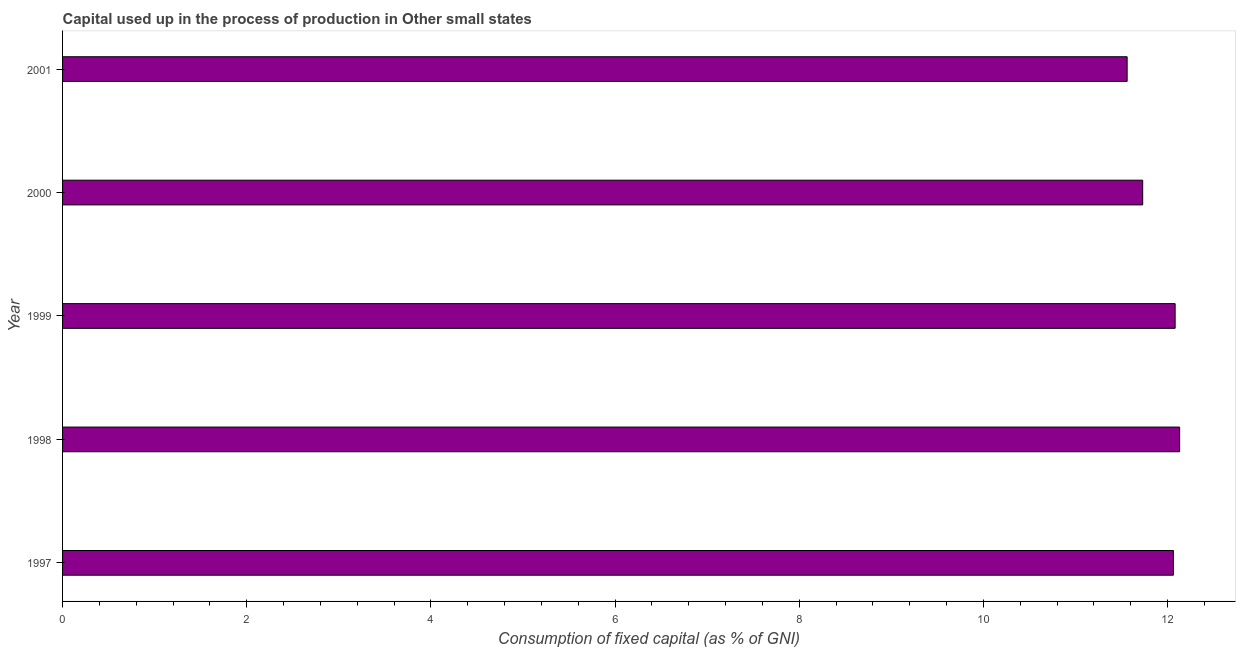Does the graph contain any zero values?
Provide a succinct answer. No. What is the title of the graph?
Your response must be concise. Capital used up in the process of production in Other small states. What is the label or title of the X-axis?
Make the answer very short. Consumption of fixed capital (as % of GNI). What is the consumption of fixed capital in 2000?
Give a very brief answer. 11.73. Across all years, what is the maximum consumption of fixed capital?
Offer a very short reply. 12.13. Across all years, what is the minimum consumption of fixed capital?
Make the answer very short. 11.56. In which year was the consumption of fixed capital maximum?
Give a very brief answer. 1998. What is the sum of the consumption of fixed capital?
Give a very brief answer. 59.57. What is the difference between the consumption of fixed capital in 1997 and 1998?
Make the answer very short. -0.07. What is the average consumption of fixed capital per year?
Offer a very short reply. 11.91. What is the median consumption of fixed capital?
Ensure brevity in your answer.  12.06. In how many years, is the consumption of fixed capital greater than 0.8 %?
Make the answer very short. 5. What is the ratio of the consumption of fixed capital in 1997 to that in 2000?
Your answer should be very brief. 1.03. Is the consumption of fixed capital in 1998 less than that in 2000?
Keep it short and to the point. No. What is the difference between the highest and the second highest consumption of fixed capital?
Offer a terse response. 0.05. What is the difference between the highest and the lowest consumption of fixed capital?
Make the answer very short. 0.57. In how many years, is the consumption of fixed capital greater than the average consumption of fixed capital taken over all years?
Give a very brief answer. 3. Are all the bars in the graph horizontal?
Make the answer very short. Yes. What is the Consumption of fixed capital (as % of GNI) of 1997?
Make the answer very short. 12.06. What is the Consumption of fixed capital (as % of GNI) in 1998?
Provide a short and direct response. 12.13. What is the Consumption of fixed capital (as % of GNI) of 1999?
Your answer should be compact. 12.08. What is the Consumption of fixed capital (as % of GNI) of 2000?
Offer a very short reply. 11.73. What is the Consumption of fixed capital (as % of GNI) of 2001?
Your response must be concise. 11.56. What is the difference between the Consumption of fixed capital (as % of GNI) in 1997 and 1998?
Offer a very short reply. -0.07. What is the difference between the Consumption of fixed capital (as % of GNI) in 1997 and 1999?
Keep it short and to the point. -0.02. What is the difference between the Consumption of fixed capital (as % of GNI) in 1997 and 2000?
Provide a succinct answer. 0.33. What is the difference between the Consumption of fixed capital (as % of GNI) in 1997 and 2001?
Provide a short and direct response. 0.5. What is the difference between the Consumption of fixed capital (as % of GNI) in 1998 and 1999?
Offer a terse response. 0.05. What is the difference between the Consumption of fixed capital (as % of GNI) in 1998 and 2000?
Keep it short and to the point. 0.4. What is the difference between the Consumption of fixed capital (as % of GNI) in 1998 and 2001?
Ensure brevity in your answer.  0.57. What is the difference between the Consumption of fixed capital (as % of GNI) in 1999 and 2000?
Make the answer very short. 0.35. What is the difference between the Consumption of fixed capital (as % of GNI) in 1999 and 2001?
Keep it short and to the point. 0.52. What is the difference between the Consumption of fixed capital (as % of GNI) in 2000 and 2001?
Offer a very short reply. 0.17. What is the ratio of the Consumption of fixed capital (as % of GNI) in 1997 to that in 1998?
Give a very brief answer. 0.99. What is the ratio of the Consumption of fixed capital (as % of GNI) in 1997 to that in 1999?
Keep it short and to the point. 1. What is the ratio of the Consumption of fixed capital (as % of GNI) in 1997 to that in 2000?
Offer a very short reply. 1.03. What is the ratio of the Consumption of fixed capital (as % of GNI) in 1997 to that in 2001?
Your answer should be compact. 1.04. What is the ratio of the Consumption of fixed capital (as % of GNI) in 1998 to that in 1999?
Your answer should be compact. 1. What is the ratio of the Consumption of fixed capital (as % of GNI) in 1998 to that in 2000?
Keep it short and to the point. 1.03. What is the ratio of the Consumption of fixed capital (as % of GNI) in 1998 to that in 2001?
Your answer should be compact. 1.05. What is the ratio of the Consumption of fixed capital (as % of GNI) in 1999 to that in 2000?
Keep it short and to the point. 1.03. What is the ratio of the Consumption of fixed capital (as % of GNI) in 1999 to that in 2001?
Keep it short and to the point. 1.04. What is the ratio of the Consumption of fixed capital (as % of GNI) in 2000 to that in 2001?
Ensure brevity in your answer.  1.01. 